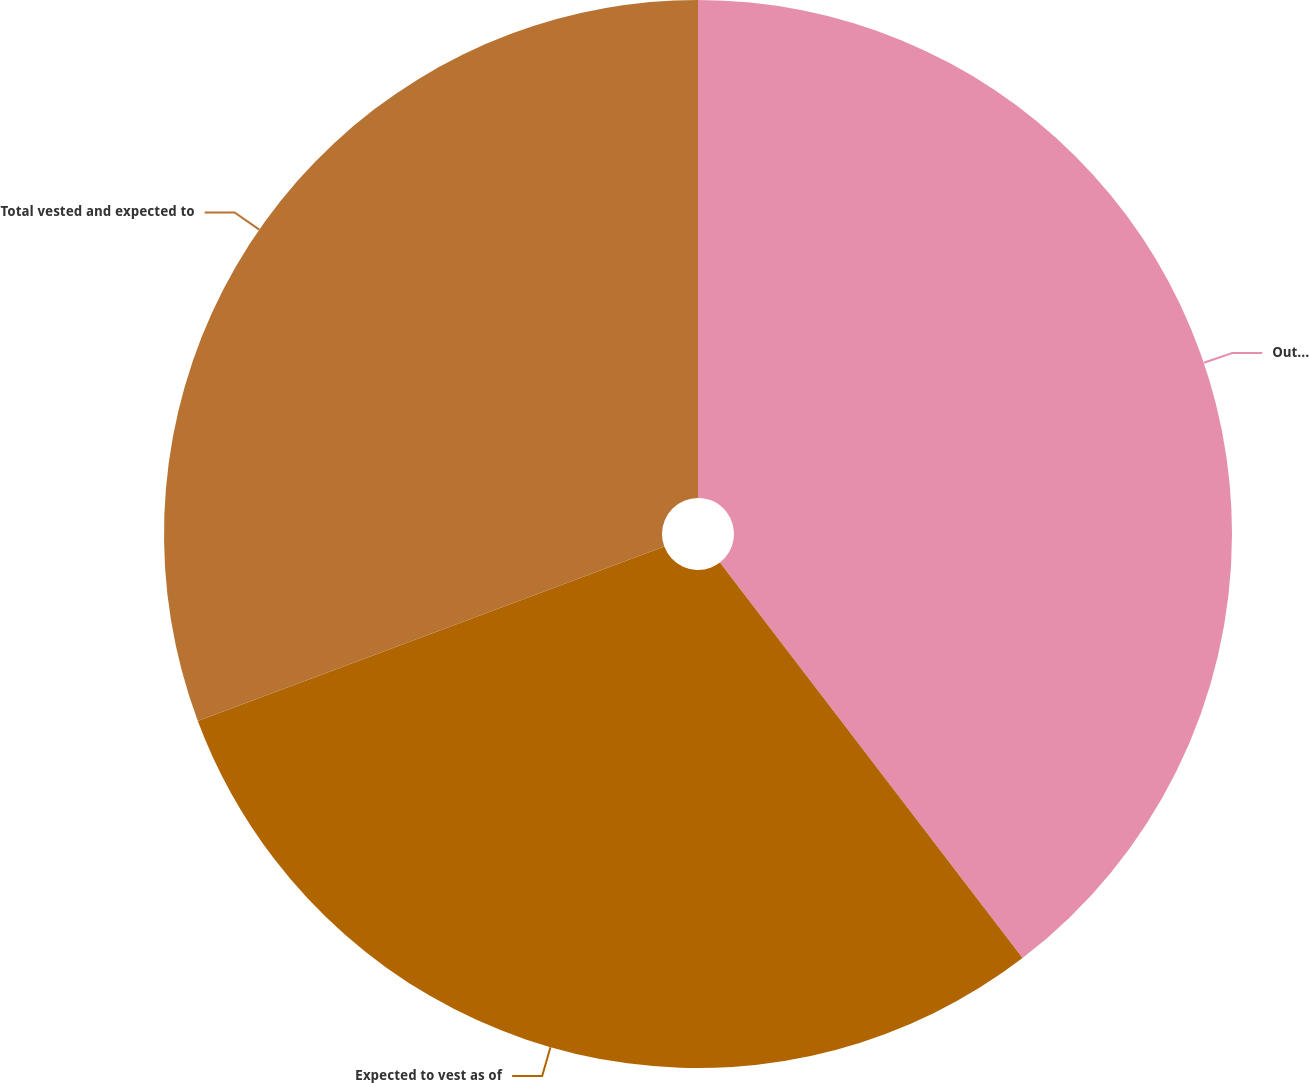Convert chart to OTSL. <chart><loc_0><loc_0><loc_500><loc_500><pie_chart><fcel>Outstanding as of December 31<fcel>Expected to vest as of<fcel>Total vested and expected to<nl><fcel>39.6%<fcel>29.7%<fcel>30.69%<nl></chart> 